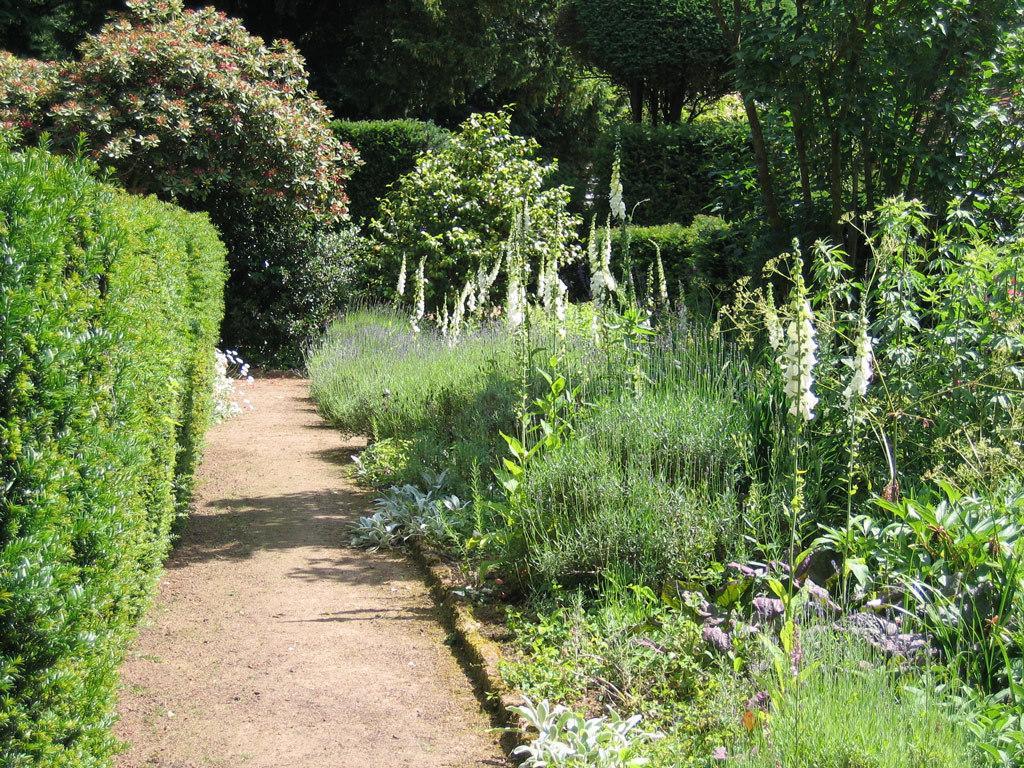In one or two sentences, can you explain what this image depicts? In this image we can see plants, flowers, and path. In the background there are trees. 